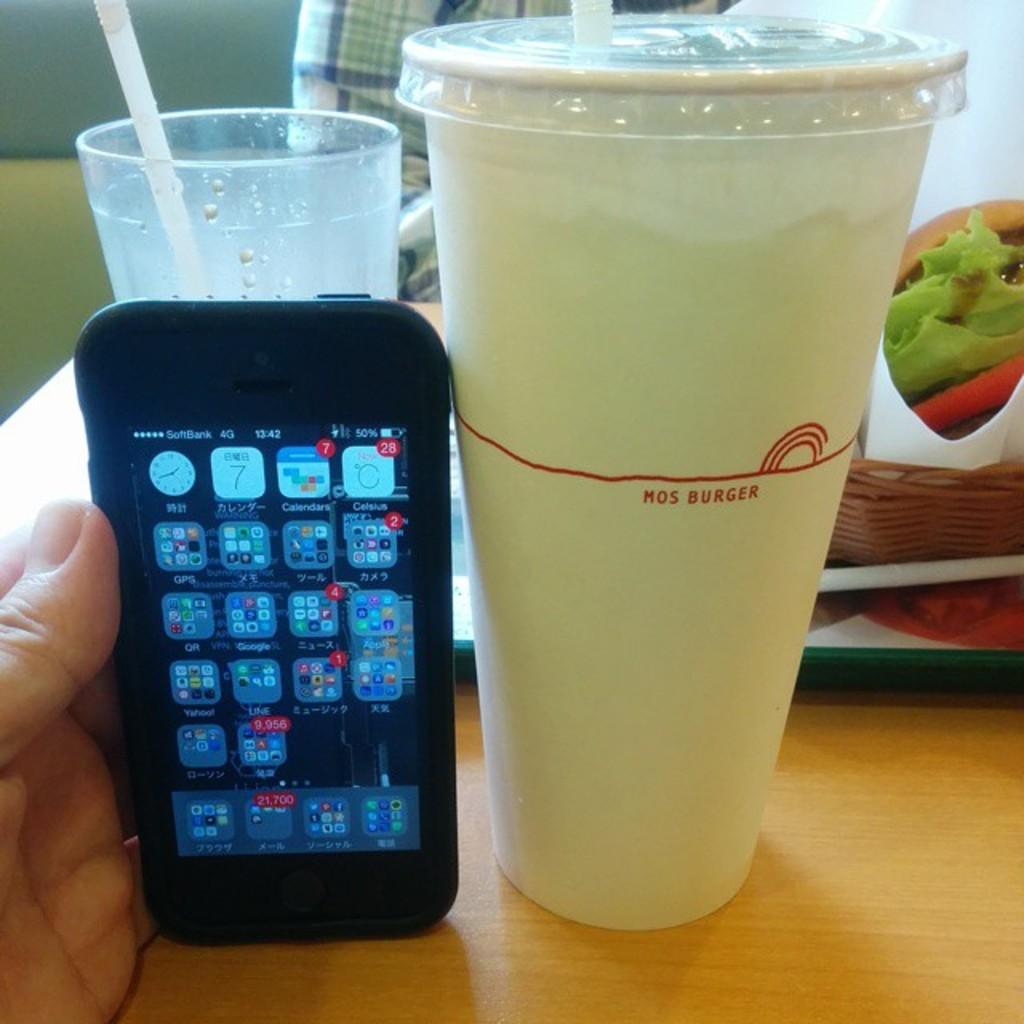Provide a one-sentence caption for the provided image. A Mos Burger drink cup is being compared to an iphone for scale. 